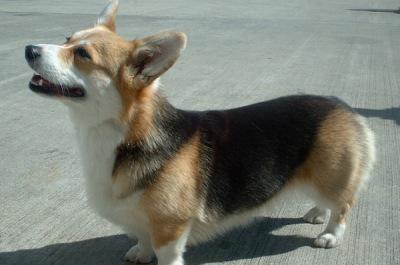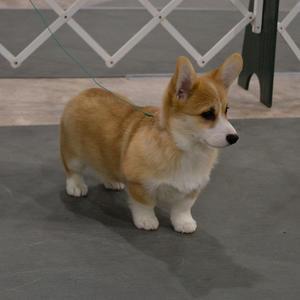The first image is the image on the left, the second image is the image on the right. Evaluate the accuracy of this statement regarding the images: "Each image shows only one dog, with the dog in the right image orange-and-white, and the dog on the left tri-colored.". Is it true? Answer yes or no. Yes. The first image is the image on the left, the second image is the image on the right. Assess this claim about the two images: "An image contains two dogs.". Correct or not? Answer yes or no. No. 